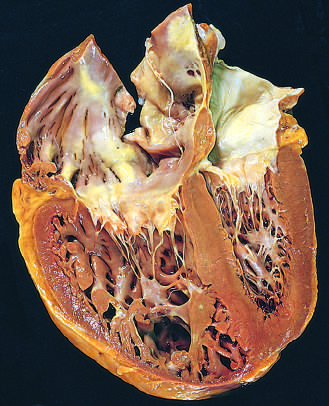have the shape and volume of the left ventricle been distorted by the enlarged right ventricle?
Answer the question using a single word or phrase. Yes 